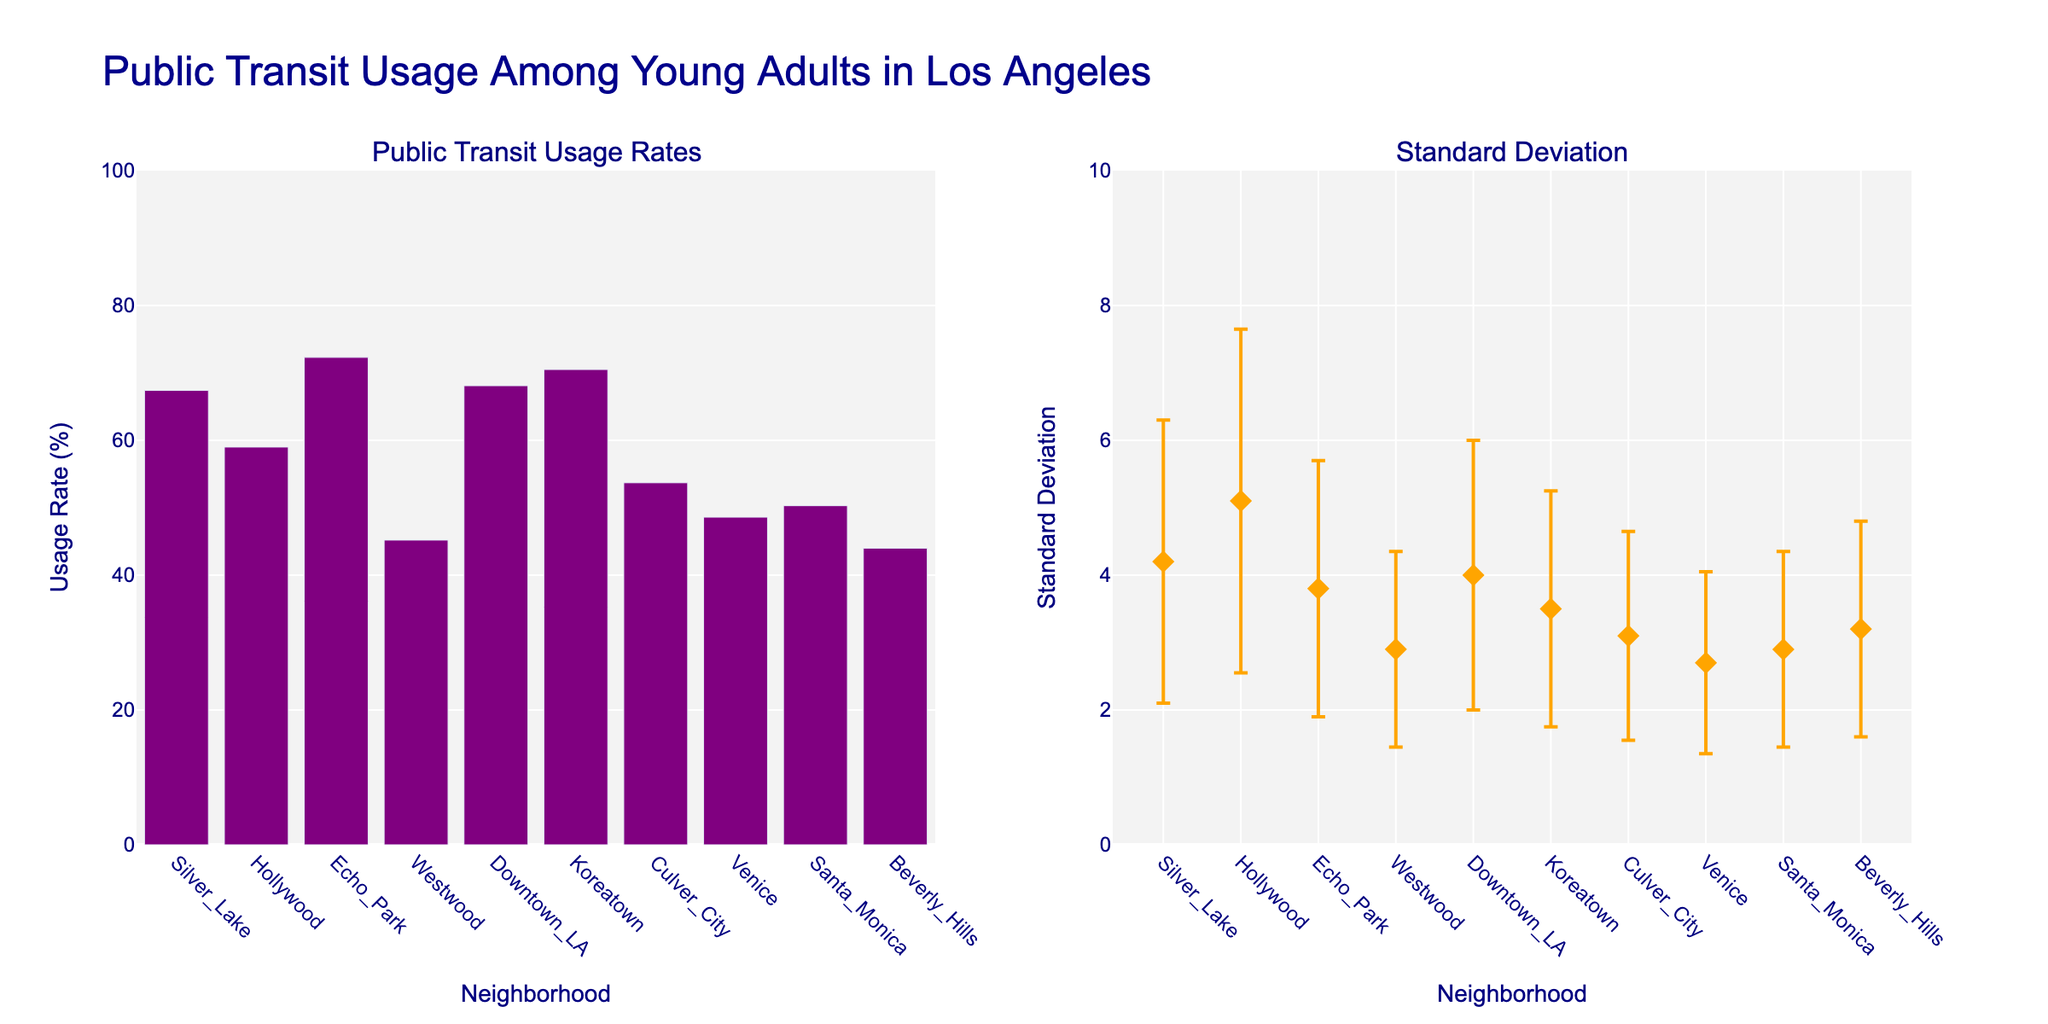What is the title of the figure? The title of the figure is displayed prominently at the top. It reads "Public Transit Usage Among Young Adults in Los Angeles."
Answer: Public Transit Usage Among Young Adults in Los Angeles Which neighborhood has the highest public transit usage rate? By looking at the bar heights in the "Public Transit Usage Rates" subplot, Echo Park has the highest bar, indicating the highest usage rate.
Answer: Echo Park What is the standard deviation of the public transit usage rate in Koreatown? In the "Standard Deviation" subplot, find Koreatown on the x-axis and check the corresponding y-axis value for standard deviation. The orange diamond marker indicates a standard deviation of 3.5.
Answer: 3.5 How does the public transit usage rate in Westwood compare to Santa Monica? In the "Public Transit Usage Rates" subplot, compare the heights of the bars for Westwood and Santa Monica. Westwood has a shorter bar at 45.2% compared to Santa Monica at 50.3%. Therefore, Westwood's usage rate is lower.
Answer: Westwood's usage rate is lower Which neighborhood has the smallest standard deviation and what is its value? In the "Standard Deviation" subplot, find the shortest orange diamond marker. Culver City has the smallest standard deviation value at 3.1.
Answer: Culver City, 3.1 What is the difference in public transit usage rates between the highest and the lowest neighborhoods? Find the highest usage rate (Echo Park at 72.3%) and the lowest usage rate (Beverly Hills at 44%). Subtract the lowest from the highest: 72.3% - 44% = 28.3%.
Answer: 28.3% Which neighborhood has the highest standard deviation but not the highest public transit usage rate? In the "Standard Deviation" subplot, find Hollywood with the highest marker at a standard deviation of 5.1, but note that the highest usage rate belongs to Echo Park, not Hollywood.
Answer: Hollywood What is the average public transit usage rate among all the neighborhoods? Add up all the public transit usage rates and divide by the number of neighborhoods. (67.4 + 59.0 + 72.3 + 45.2 + 68.1 + 70.5 + 53.7 + 48.6 + 50.3 + 44.0) / 10 = 57.91%.
Answer: 57.91% Are there any neighborhoods with a public transit usage rate below 50%? If so, which ones? In the "Public Transit Usage Rates" subplot, find bars that are below the 50% mark on the y-axis. Westwood, Venice, Santa Monica, and Beverly Hills all have rates below 50%.
Answer: Westwood, Venice, Santa Monica, Beverly Hills 